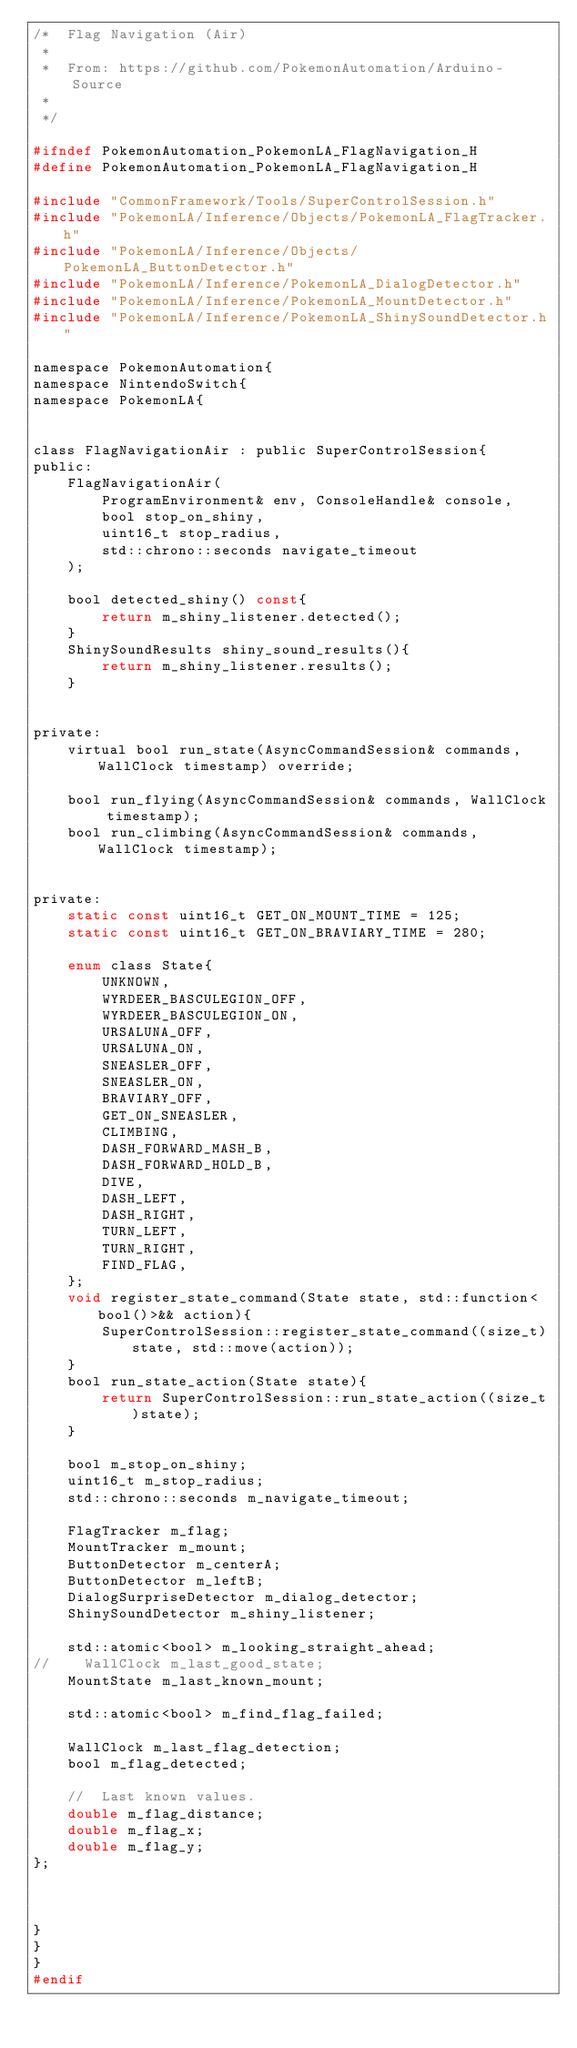Convert code to text. <code><loc_0><loc_0><loc_500><loc_500><_C_>/*  Flag Navigation (Air)
 *
 *  From: https://github.com/PokemonAutomation/Arduino-Source
 *
 */

#ifndef PokemonAutomation_PokemonLA_FlagNavigation_H
#define PokemonAutomation_PokemonLA_FlagNavigation_H

#include "CommonFramework/Tools/SuperControlSession.h"
#include "PokemonLA/Inference/Objects/PokemonLA_FlagTracker.h"
#include "PokemonLA/Inference/Objects/PokemonLA_ButtonDetector.h"
#include "PokemonLA/Inference/PokemonLA_DialogDetector.h"
#include "PokemonLA/Inference/PokemonLA_MountDetector.h"
#include "PokemonLA/Inference/PokemonLA_ShinySoundDetector.h"

namespace PokemonAutomation{
namespace NintendoSwitch{
namespace PokemonLA{


class FlagNavigationAir : public SuperControlSession{
public:
    FlagNavigationAir(
        ProgramEnvironment& env, ConsoleHandle& console,
        bool stop_on_shiny,
        uint16_t stop_radius,
        std::chrono::seconds navigate_timeout
    );

    bool detected_shiny() const{
        return m_shiny_listener.detected();
    }
    ShinySoundResults shiny_sound_results(){
        return m_shiny_listener.results();
    }


private:
    virtual bool run_state(AsyncCommandSession& commands, WallClock timestamp) override;

    bool run_flying(AsyncCommandSession& commands, WallClock timestamp);
    bool run_climbing(AsyncCommandSession& commands, WallClock timestamp);


private:
    static const uint16_t GET_ON_MOUNT_TIME = 125;
    static const uint16_t GET_ON_BRAVIARY_TIME = 280;

    enum class State{
        UNKNOWN,
        WYRDEER_BASCULEGION_OFF,
        WYRDEER_BASCULEGION_ON,
        URSALUNA_OFF,
        URSALUNA_ON,
        SNEASLER_OFF,
        SNEASLER_ON,
        BRAVIARY_OFF,
        GET_ON_SNEASLER,
        CLIMBING,
        DASH_FORWARD_MASH_B,
        DASH_FORWARD_HOLD_B,
        DIVE,
        DASH_LEFT,
        DASH_RIGHT,
        TURN_LEFT,
        TURN_RIGHT,
        FIND_FLAG,
    };
    void register_state_command(State state, std::function<bool()>&& action){
        SuperControlSession::register_state_command((size_t)state, std::move(action));
    }
    bool run_state_action(State state){
        return SuperControlSession::run_state_action((size_t)state);
    }

    bool m_stop_on_shiny;
    uint16_t m_stop_radius;
    std::chrono::seconds m_navigate_timeout;

    FlagTracker m_flag;
    MountTracker m_mount;
    ButtonDetector m_centerA;
    ButtonDetector m_leftB;
    DialogSurpriseDetector m_dialog_detector;
    ShinySoundDetector m_shiny_listener;

    std::atomic<bool> m_looking_straight_ahead;
//    WallClock m_last_good_state;
    MountState m_last_known_mount;

    std::atomic<bool> m_find_flag_failed;

    WallClock m_last_flag_detection;
    bool m_flag_detected;

    //  Last known values.
    double m_flag_distance;
    double m_flag_x;
    double m_flag_y;
};



}
}
}
#endif
</code> 